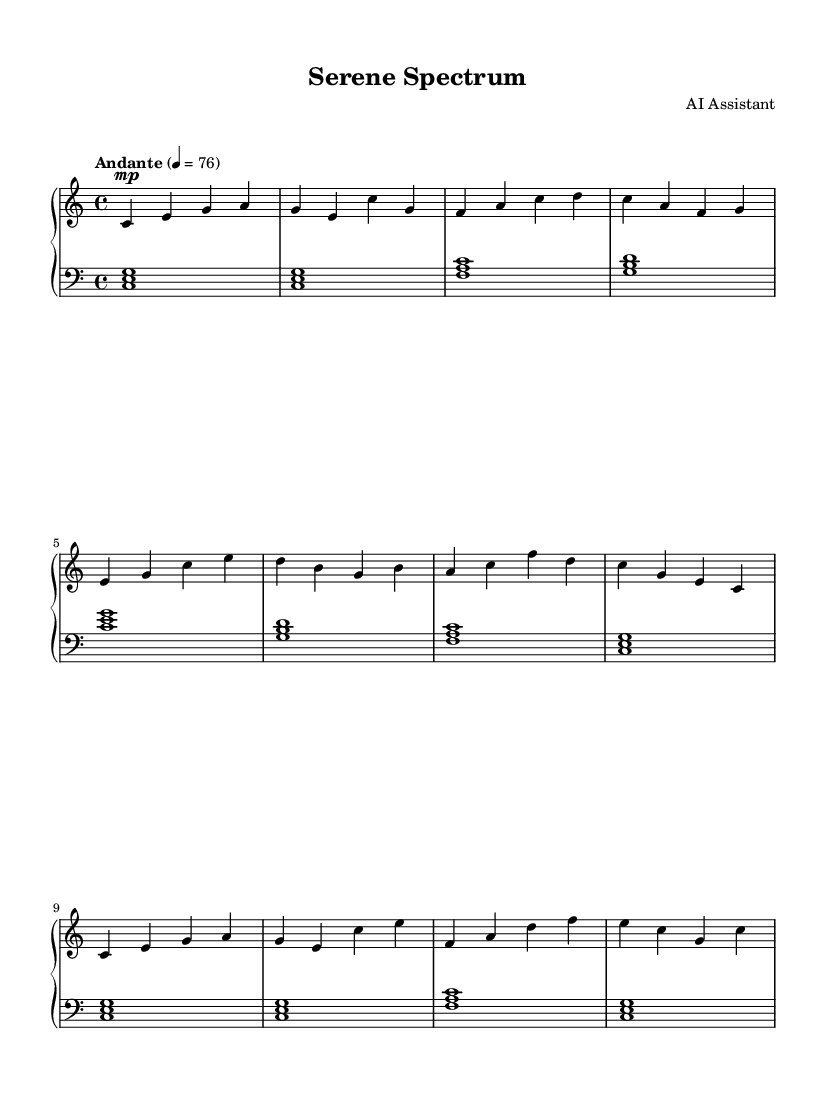What is the key signature of this music? The key signature is indicated at the beginning of the sheet music. It is C major, which has no sharps or flats.
Answer: C major What is the time signature of this music? The time signature is shown at the beginning of the piece. It is 4/4, meaning there are four beats per measure, with a quarter note receiving one beat.
Answer: 4/4 What is the tempo marking of this piece? The tempo marking is found in the top section of the sheet music. It indicates "Andante," which means a moderately slow tempo.
Answer: Andante How many measures are in section A? By counting the measures in the A section (the first part of the piece), we see there are 4 measures.
Answer: 4 How many times does section A repeat? The A section is labeled and is followed by an A' section, which indicates that it appears once in its original form and once in a modified form, making it repeat one complete time.
Answer: 1 What is the highest note in the right-hand part? Analyzing the right-hand part, the highest note is C in the octave 'c' range, marked at the end of the A' section.
Answer: c' What is the interval between the left-hand notes in the first measure? In the first measure of the left hand, the notes are a chord made up of C, E, and G, which form a major chord. The distance from C to E is a major third.
Answer: Major third 